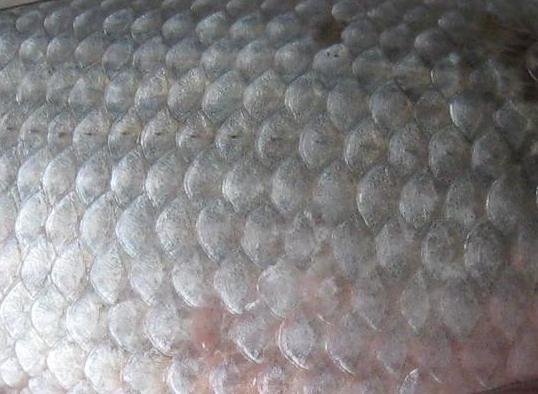What does the specific arrangement of these scales suggest about the fluid dynamics the creature might experience? The precise overlapping arrangement of the scales as seen in the image plays a critical role in optimizing fluid dynamics. The layered configuration reduces drag and turbulence while the creature moves in water, enabling swifter and more energy-efficient movement. This biological adaptation suggests a highly evolved mechanism geared towards enhancing locomotion in aquatic habitats, possibly influencing the creature's ability to hunt or evade predators efficiently. 